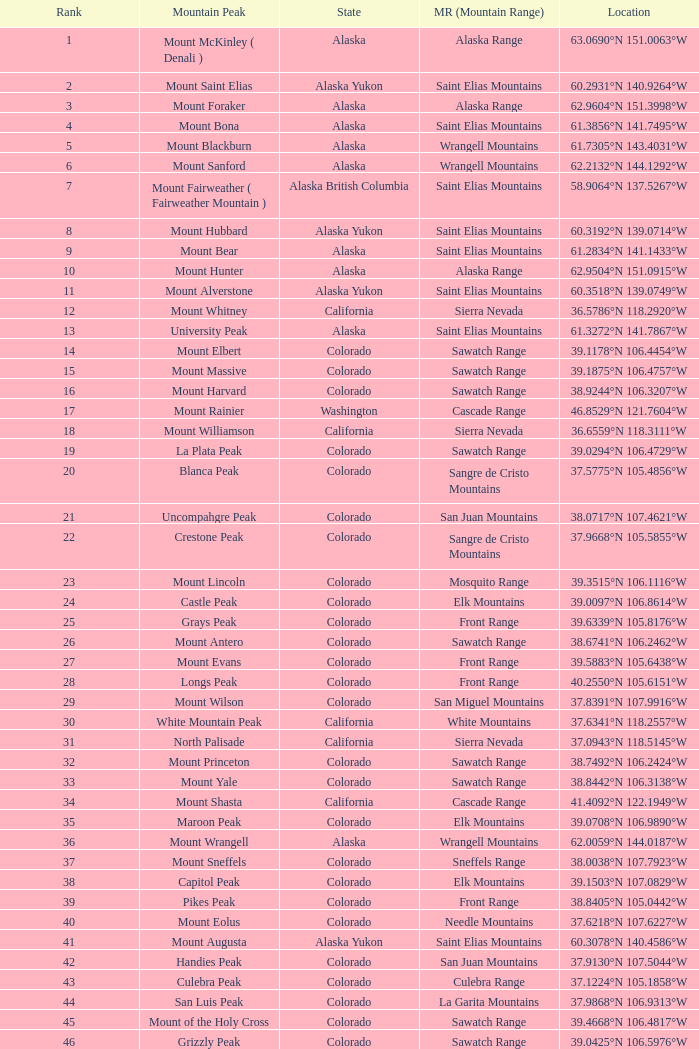What is the rank when the state is colorado and the location is 37.7859°n 107.7039°w? 83.0. 